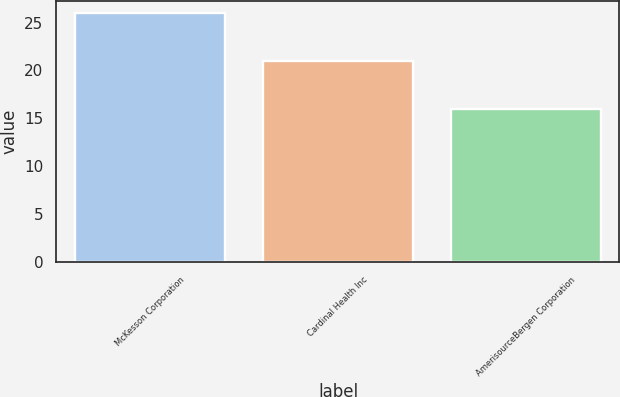Convert chart to OTSL. <chart><loc_0><loc_0><loc_500><loc_500><bar_chart><fcel>McKesson Corporation<fcel>Cardinal Health Inc<fcel>AmerisourceBergen Corporation<nl><fcel>26<fcel>21<fcel>16<nl></chart> 